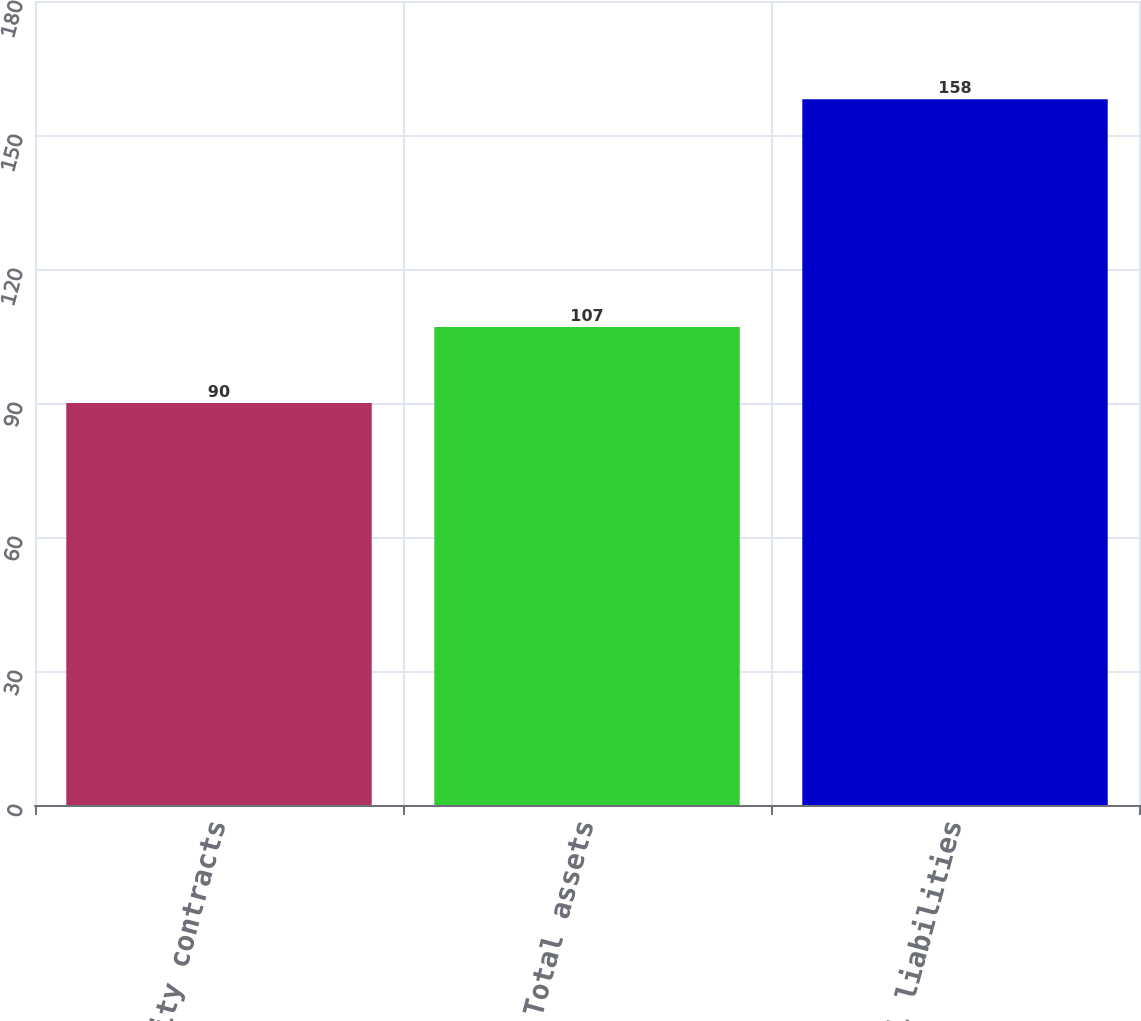Convert chart to OTSL. <chart><loc_0><loc_0><loc_500><loc_500><bar_chart><fcel>Commodity contracts<fcel>Total assets<fcel>Total liabilities<nl><fcel>90<fcel>107<fcel>158<nl></chart> 